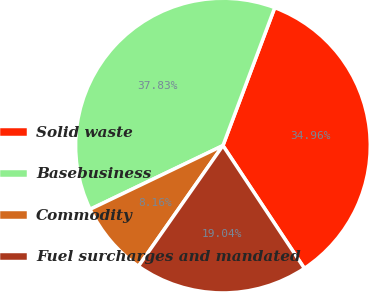Convert chart to OTSL. <chart><loc_0><loc_0><loc_500><loc_500><pie_chart><fcel>Solid waste<fcel>Basebusiness<fcel>Commodity<fcel>Fuel surcharges and mandated<nl><fcel>34.96%<fcel>37.83%<fcel>8.16%<fcel>19.04%<nl></chart> 